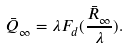Convert formula to latex. <formula><loc_0><loc_0><loc_500><loc_500>\bar { Q } _ { \infty } = \lambda F _ { d } ( \frac { \bar { R } _ { \infty } } { \lambda } ) .</formula> 